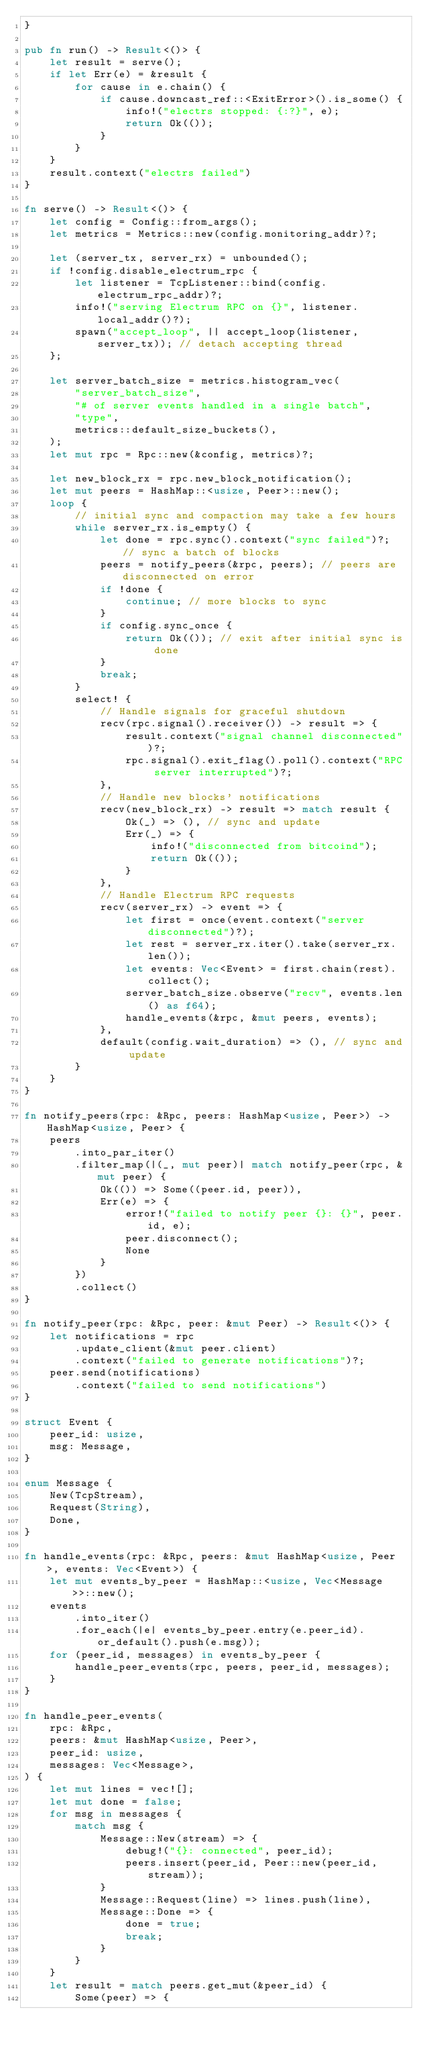<code> <loc_0><loc_0><loc_500><loc_500><_Rust_>}

pub fn run() -> Result<()> {
    let result = serve();
    if let Err(e) = &result {
        for cause in e.chain() {
            if cause.downcast_ref::<ExitError>().is_some() {
                info!("electrs stopped: {:?}", e);
                return Ok(());
            }
        }
    }
    result.context("electrs failed")
}

fn serve() -> Result<()> {
    let config = Config::from_args();
    let metrics = Metrics::new(config.monitoring_addr)?;

    let (server_tx, server_rx) = unbounded();
    if !config.disable_electrum_rpc {
        let listener = TcpListener::bind(config.electrum_rpc_addr)?;
        info!("serving Electrum RPC on {}", listener.local_addr()?);
        spawn("accept_loop", || accept_loop(listener, server_tx)); // detach accepting thread
    };

    let server_batch_size = metrics.histogram_vec(
        "server_batch_size",
        "# of server events handled in a single batch",
        "type",
        metrics::default_size_buckets(),
    );
    let mut rpc = Rpc::new(&config, metrics)?;

    let new_block_rx = rpc.new_block_notification();
    let mut peers = HashMap::<usize, Peer>::new();
    loop {
        // initial sync and compaction may take a few hours
        while server_rx.is_empty() {
            let done = rpc.sync().context("sync failed")?; // sync a batch of blocks
            peers = notify_peers(&rpc, peers); // peers are disconnected on error
            if !done {
                continue; // more blocks to sync
            }
            if config.sync_once {
                return Ok(()); // exit after initial sync is done
            }
            break;
        }
        select! {
            // Handle signals for graceful shutdown
            recv(rpc.signal().receiver()) -> result => {
                result.context("signal channel disconnected")?;
                rpc.signal().exit_flag().poll().context("RPC server interrupted")?;
            },
            // Handle new blocks' notifications
            recv(new_block_rx) -> result => match result {
                Ok(_) => (), // sync and update
                Err(_) => {
                    info!("disconnected from bitcoind");
                    return Ok(());
                }
            },
            // Handle Electrum RPC requests
            recv(server_rx) -> event => {
                let first = once(event.context("server disconnected")?);
                let rest = server_rx.iter().take(server_rx.len());
                let events: Vec<Event> = first.chain(rest).collect();
                server_batch_size.observe("recv", events.len() as f64);
                handle_events(&rpc, &mut peers, events);
            },
            default(config.wait_duration) => (), // sync and update
        }
    }
}

fn notify_peers(rpc: &Rpc, peers: HashMap<usize, Peer>) -> HashMap<usize, Peer> {
    peers
        .into_par_iter()
        .filter_map(|(_, mut peer)| match notify_peer(rpc, &mut peer) {
            Ok(()) => Some((peer.id, peer)),
            Err(e) => {
                error!("failed to notify peer {}: {}", peer.id, e);
                peer.disconnect();
                None
            }
        })
        .collect()
}

fn notify_peer(rpc: &Rpc, peer: &mut Peer) -> Result<()> {
    let notifications = rpc
        .update_client(&mut peer.client)
        .context("failed to generate notifications")?;
    peer.send(notifications)
        .context("failed to send notifications")
}

struct Event {
    peer_id: usize,
    msg: Message,
}

enum Message {
    New(TcpStream),
    Request(String),
    Done,
}

fn handle_events(rpc: &Rpc, peers: &mut HashMap<usize, Peer>, events: Vec<Event>) {
    let mut events_by_peer = HashMap::<usize, Vec<Message>>::new();
    events
        .into_iter()
        .for_each(|e| events_by_peer.entry(e.peer_id).or_default().push(e.msg));
    for (peer_id, messages) in events_by_peer {
        handle_peer_events(rpc, peers, peer_id, messages);
    }
}

fn handle_peer_events(
    rpc: &Rpc,
    peers: &mut HashMap<usize, Peer>,
    peer_id: usize,
    messages: Vec<Message>,
) {
    let mut lines = vec![];
    let mut done = false;
    for msg in messages {
        match msg {
            Message::New(stream) => {
                debug!("{}: connected", peer_id);
                peers.insert(peer_id, Peer::new(peer_id, stream));
            }
            Message::Request(line) => lines.push(line),
            Message::Done => {
                done = true;
                break;
            }
        }
    }
    let result = match peers.get_mut(&peer_id) {
        Some(peer) => {</code> 